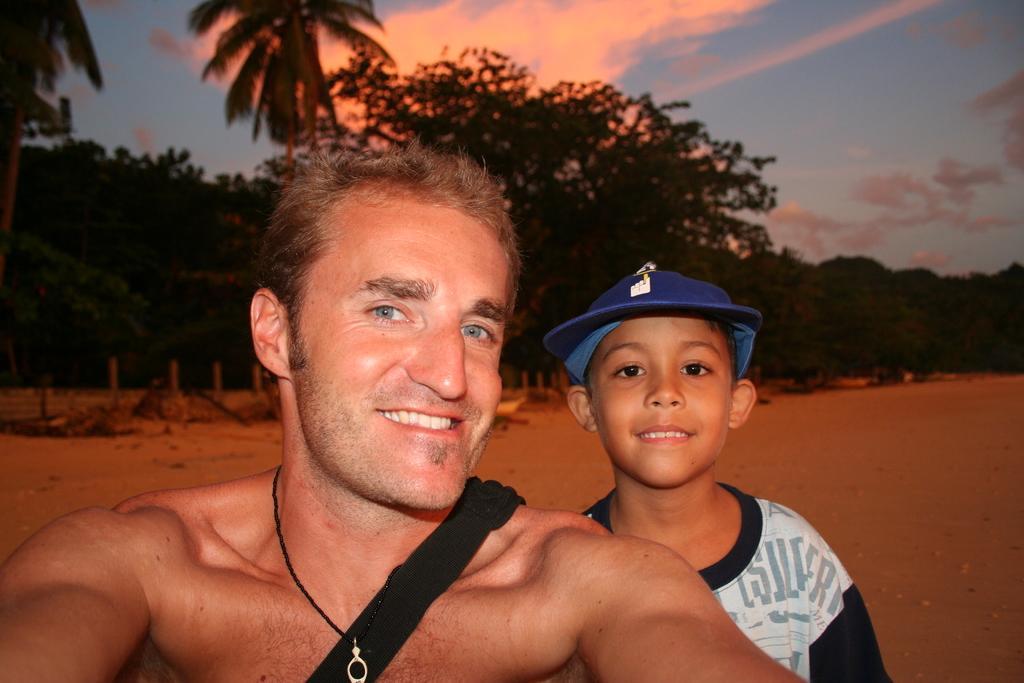Can you describe this image briefly? In this picture I can see there is a man and a kid, both are smiling, the boy is wearing a cap, the man is wearing a bag. There is sand, trees in the backdrop and the sky is clear. 